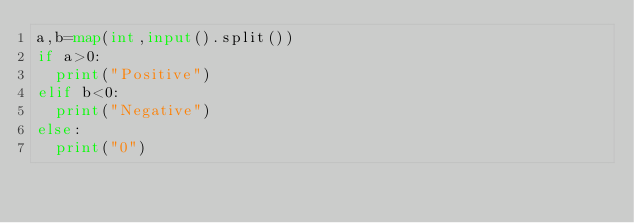Convert code to text. <code><loc_0><loc_0><loc_500><loc_500><_Python_>a,b=map(int,input().split())
if a>0:
  print("Positive") 
elif b<0:
  print("Negative")
else:
  print("0") 

</code> 